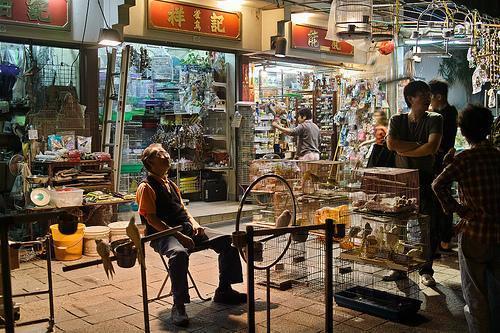How many birds are not in a cage?
Give a very brief answer. 3. 